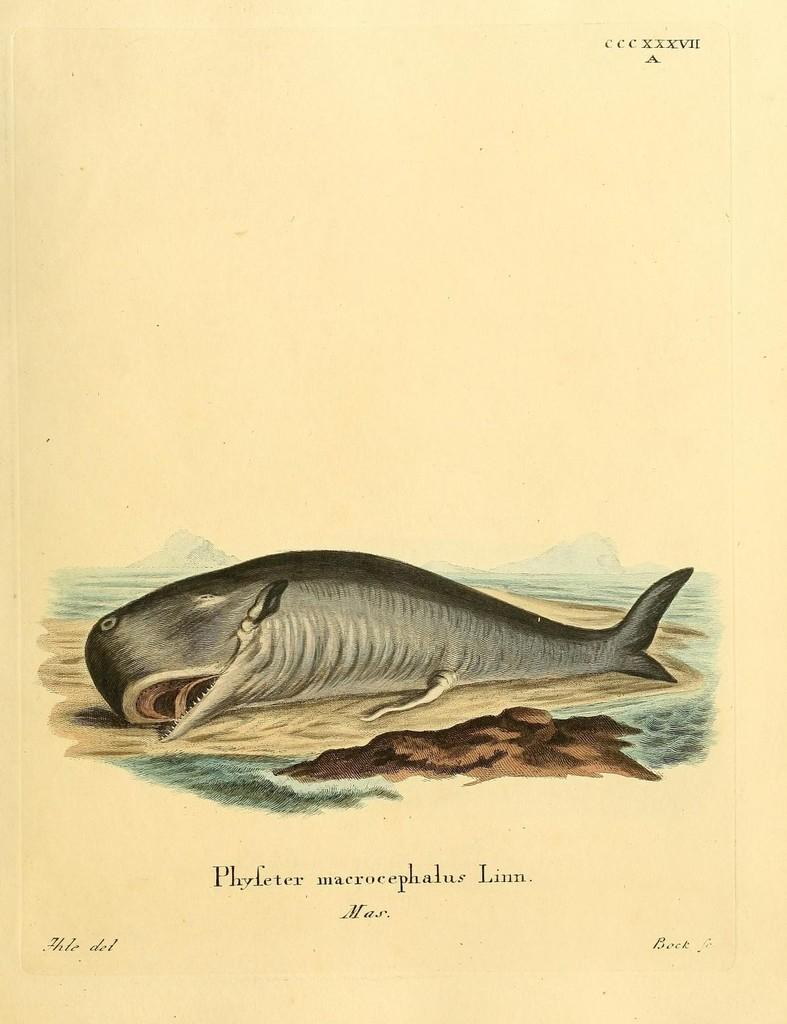What type of animal is in the image? The type of animal cannot be determined from the provided facts. Can you describe the background of the image? The background of the image cannot be described with the given information. What is written at the top of the image? There is text at the top of the image, but its content cannot be determined from the facts. What is written at the bottom of the image? There is text at the bottom of the image, but its content cannot be determined from the facts. What type of pin is holding the jar in the image? There is no pin or jar present in the image. How many turkeys are interacting with the animal in the image? There is no mention of turkeys in the image, so it cannot be determined how they might interact with the animal. 